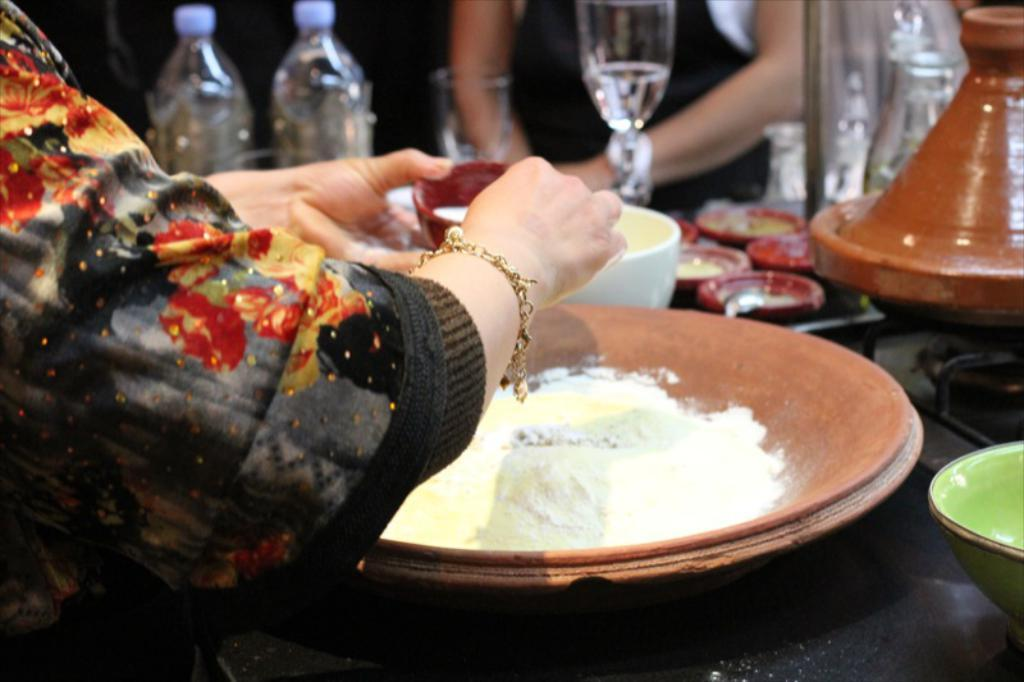What type of items can be seen in the image? There are pottery items in the image. What is in the bowl that is visible in the image? There is flour in a bowl in the image. What type of container is present in the image? There is a glass and a jar in the image. What type of beverage containers are visible in the image? There are water bottles in the image. Whose hand is visible in the image? A woman's hand is visible in the image. Can you see a lake in the image? No, there is no lake present in the image. What type of process is being carried out by the woman's hand in the image? There is no specific process being carried out by the woman's hand in the image; it is simply visible. 